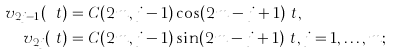Convert formula to latex. <formula><loc_0><loc_0><loc_500><loc_500>v _ { 2 j - 1 } ( \ t ) & = C ( 2 m , j - 1 ) \cos ( 2 m - j + 1 ) \ t , \\ v _ { 2 j } ( \ t ) & = C ( 2 m , j - 1 ) \sin ( 2 m - j + 1 ) \ t , j = 1 , \dots , m ;</formula> 